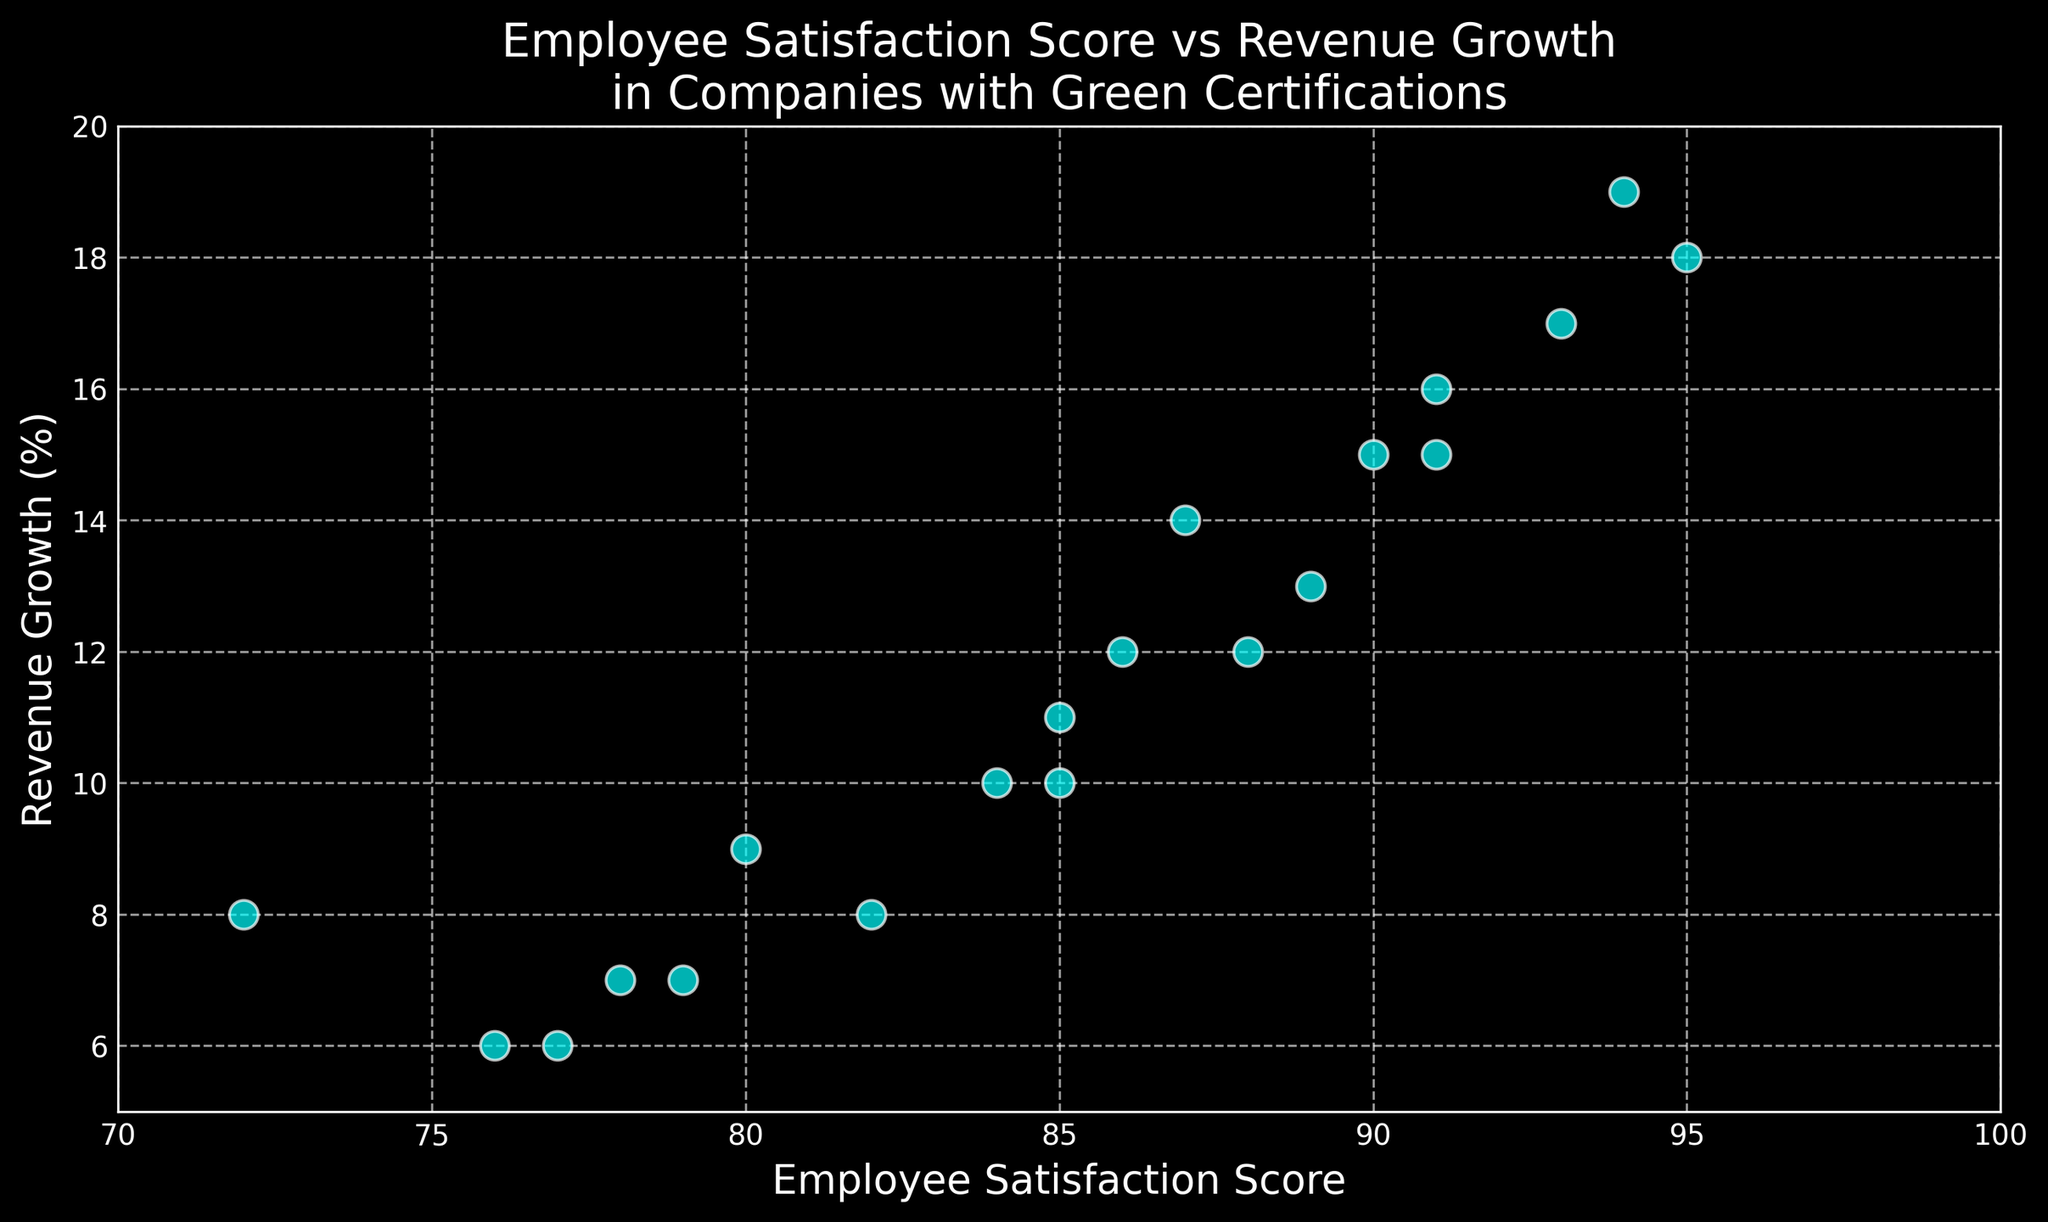What is the highest Employee Satisfaction Score shown in the plot? The highest value on the x-axis corresponds to the Employee Satisfaction Score. The plot shows 95 as the highest score.
Answer: 95 What is the range of Revenue Growth percentages shown in the plot? To determine the range, we find the minimum and maximum Revenue Growth values on the y-axis. The minimum is 6% and the maximum is 19%, so the range is 19% - 6% = 13%.
Answer: 13% Which company has the lowest Revenue Growth with an Employee Satisfaction Score above 90? To answer, we look for points where the Employee Satisfaction Score is greater than 90 on the x-axis, and among these, identify the one with the lowest y-axis value for Revenue Growth. The point (91, 15) has the lowest Revenue Growth of 15% among these points.
Answer: 15% Is there a correlation between Employee Satisfaction Scores and Revenue Growth? From the scatter plot, observe whether the points tend to rise together. Most points on the plot show a trend where higher Employee Satisfaction Scores are associated with higher Revenue Growth, indicating a positive correlation.
Answer: Yes What is the average Revenue Growth for companies with Employee Satisfaction Scores between 80 and 90? Identify points with Employee Satisfaction Scores in the range [80, 90], then average their Revenue Growth values. The points are (85, 10), (88, 12), (90, 15), (85, 11), (89, 13), (82, 8), (87, 14), (84, 10), and (86, 12). Their Revenue Growth values are 10, 12, 15, 11, 13, 8, 14, 10, and 12. Average is (10+12+15+11+13+8+14+10+12)/9 = 11.67%.
Answer: 11.67% Which Employee Satisfaction Score is associated with the highest Revenue Growth? To find this, identify the highest y-axis value (Revenue Growth) and check its corresponding x-axis value (Employee Satisfaction Score). The highest Revenue Growth is 19%, corresponding to an Employee Satisfaction Score of 94.
Answer: 94 How many companies have an Employee Satisfaction Score of exactly 85? Look for the number of points where the x-axis value is 85. There are two such points on the plot (85, 10) and (85, 11). Therefore, two companies have this exact score.
Answer: 2 Which color represents the data points and what visual effect does this color have on the dark background? The data points are colored cyan, standing out against the dark background. This high contrast makes the points easily distinguishable and visually appealing.
Answer: Cyan What is the median Employee Satisfaction Score for the companies shown in the plot? Arrange all Employee Satisfaction Scores in ascending order and identify the middle value. The scores are: 72, 76, 77, 78, 79, 80, 82, 84, 85, 85, 86, 87, 88, 89, 90, 91, 91, 93, 94, 95. The middle (10th and 11th) values are 85, so the median is (85+85)/2 = 85.
Answer: 85 Which data points have the highest density based on visual inspection, and what could this indicate? Visually, the points seem dense around Employee Satisfaction Scores of 85-90 and Revenue Growth between 10-15. This higher density suggests a clustering of companies with moderately high satisfaction and growth values.
Answer: Around 85-90 and 10-15 